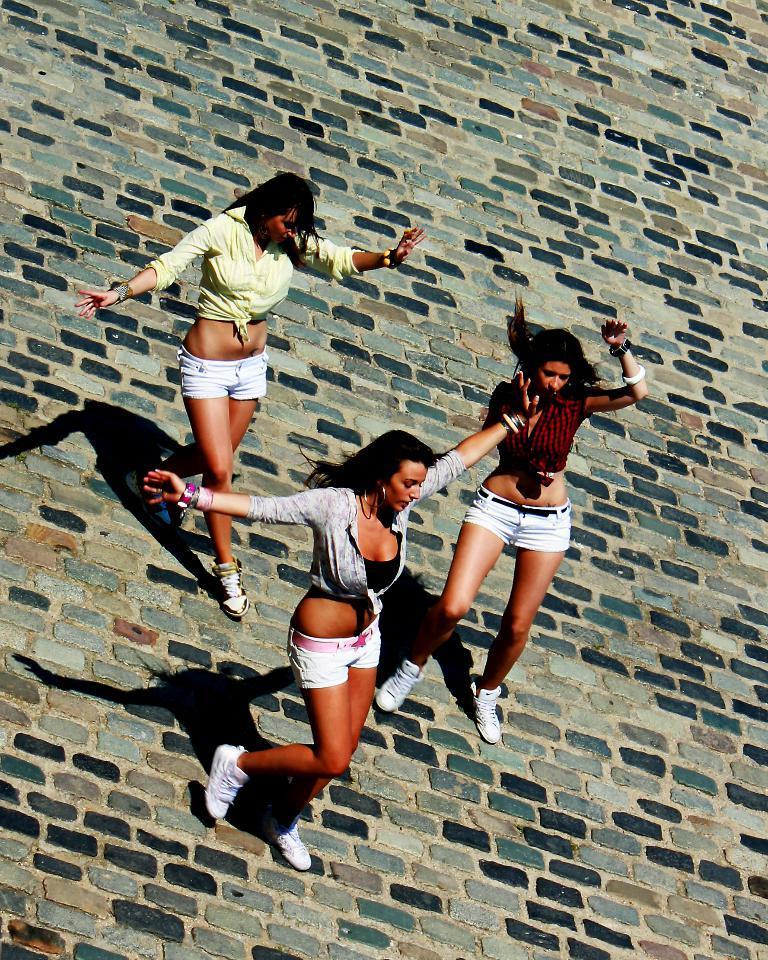In one or two sentences, can you explain what this image depicts? In the middle of the image three women are standing and doing something. 